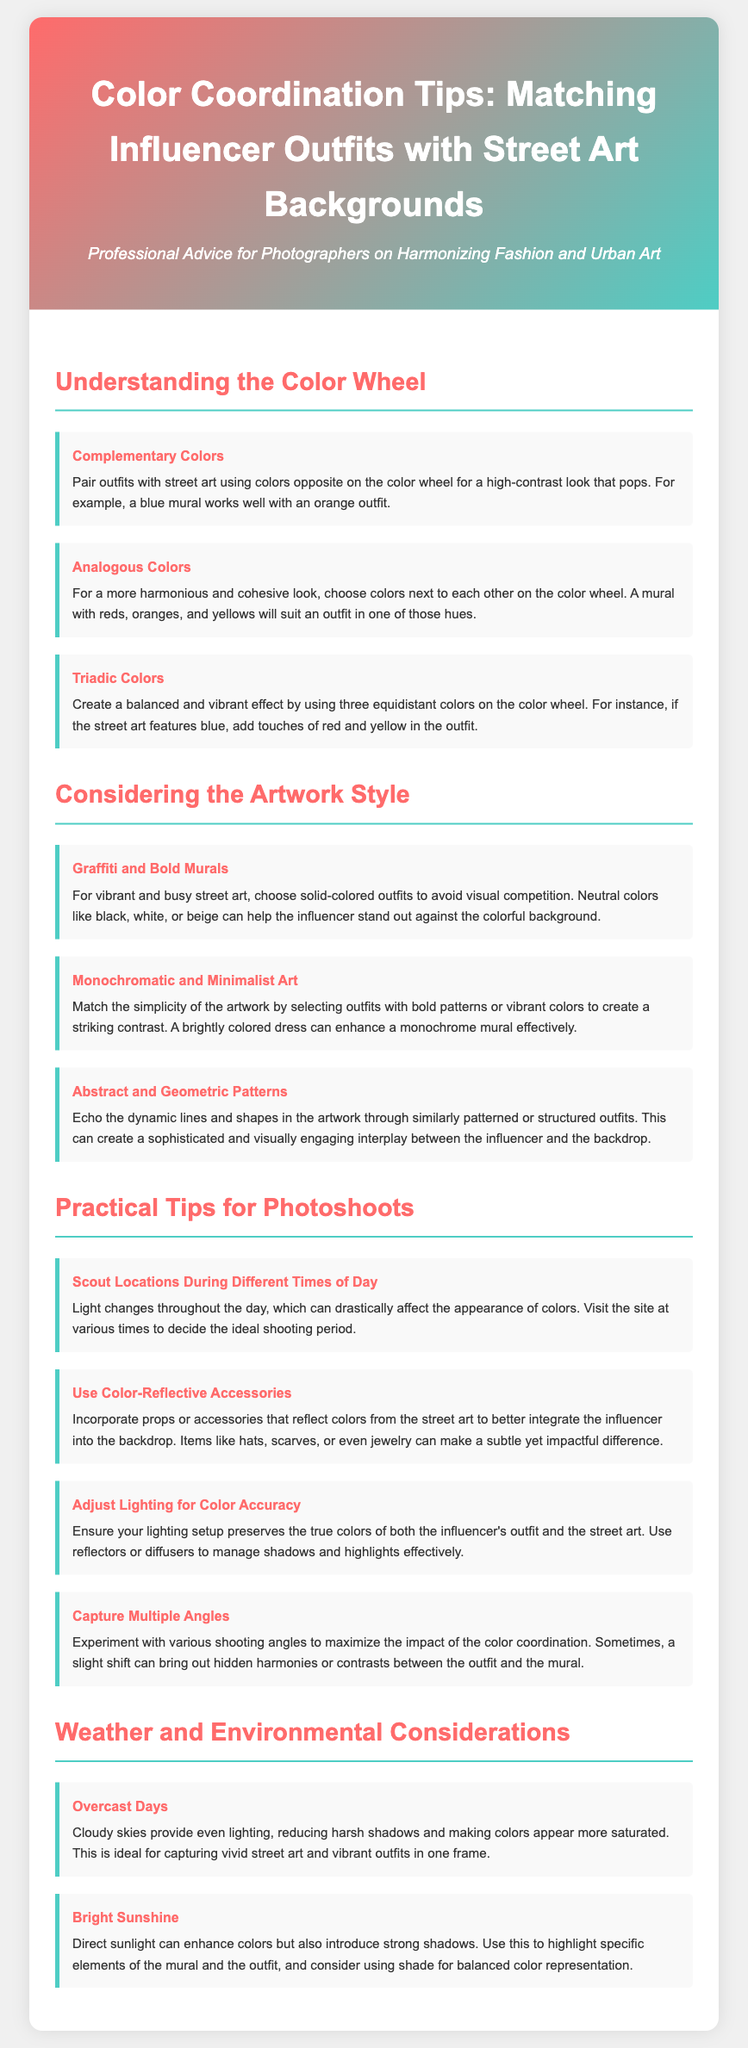what are the two types of color schemes mentioned? The document discusses complementary and analogous colors as types of color schemes for fashion and street art coordination.
Answer: complementary and analogous colors what is recommended for vibrant street art? The tip suggests selecting solid-colored outfits to avoid visual competition with vibrant and busy street art.
Answer: solid-colored outfits how should outfits be chosen for monochromatic art? Outfits with bold patterns or vibrant colors should be selected to create a striking contrast against monochrome artwork.
Answer: bold patterns or vibrant colors what element should be considered when scouting locations? The light changes throughout the day should be considered when scouting locations, as it affects color appearance.
Answer: light changes how can props enhance the integration of outfits with street art? Color-reflective accessories like hats, scarves, or jewelry can make a subtle yet impactful difference in integrating outfits with street art.
Answer: color-reflective accessories what effect do overcast days have on photography? Overcast days provide even lighting that reduces harsh shadows and makes colors appear more saturated, ideal for vivid captures.
Answer: even lighting what should be adjusted for color accuracy? Lighting setups should be adjusted to preserve the true colors of the influencer's outfit and the street art.
Answer: lighting setups how many color coordination tips are provided in the section? The section provides a total of twelve tips for color coordination in fashion photography against street art.
Answer: twelve tips 